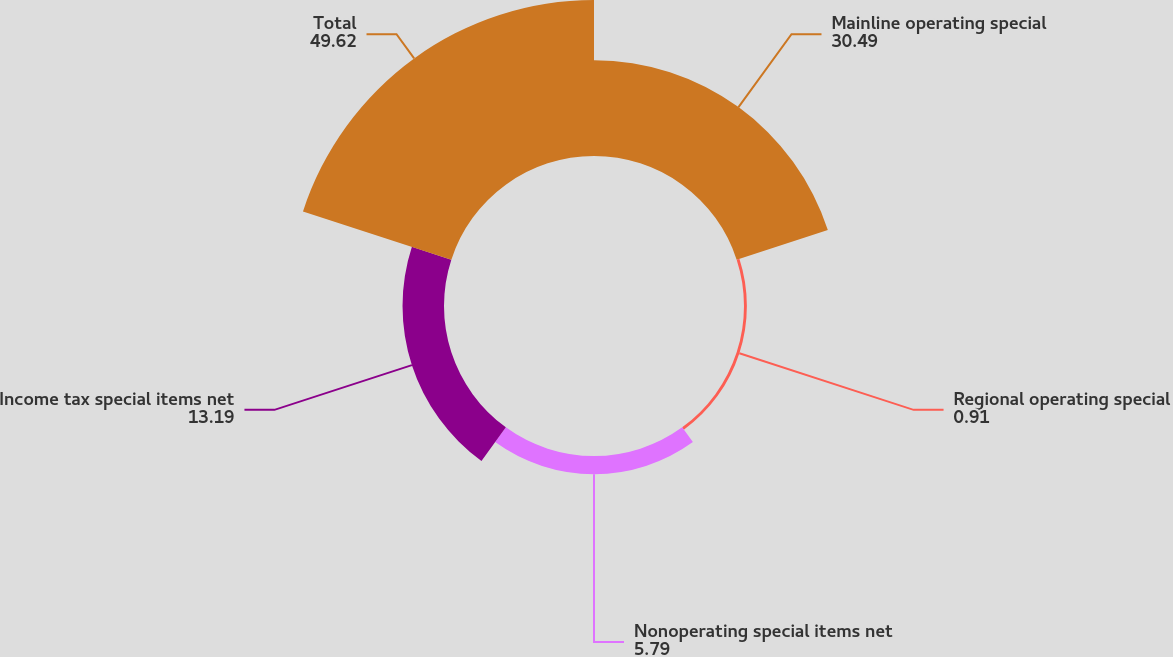<chart> <loc_0><loc_0><loc_500><loc_500><pie_chart><fcel>Mainline operating special<fcel>Regional operating special<fcel>Nonoperating special items net<fcel>Income tax special items net<fcel>Total<nl><fcel>30.49%<fcel>0.91%<fcel>5.79%<fcel>13.19%<fcel>49.62%<nl></chart> 